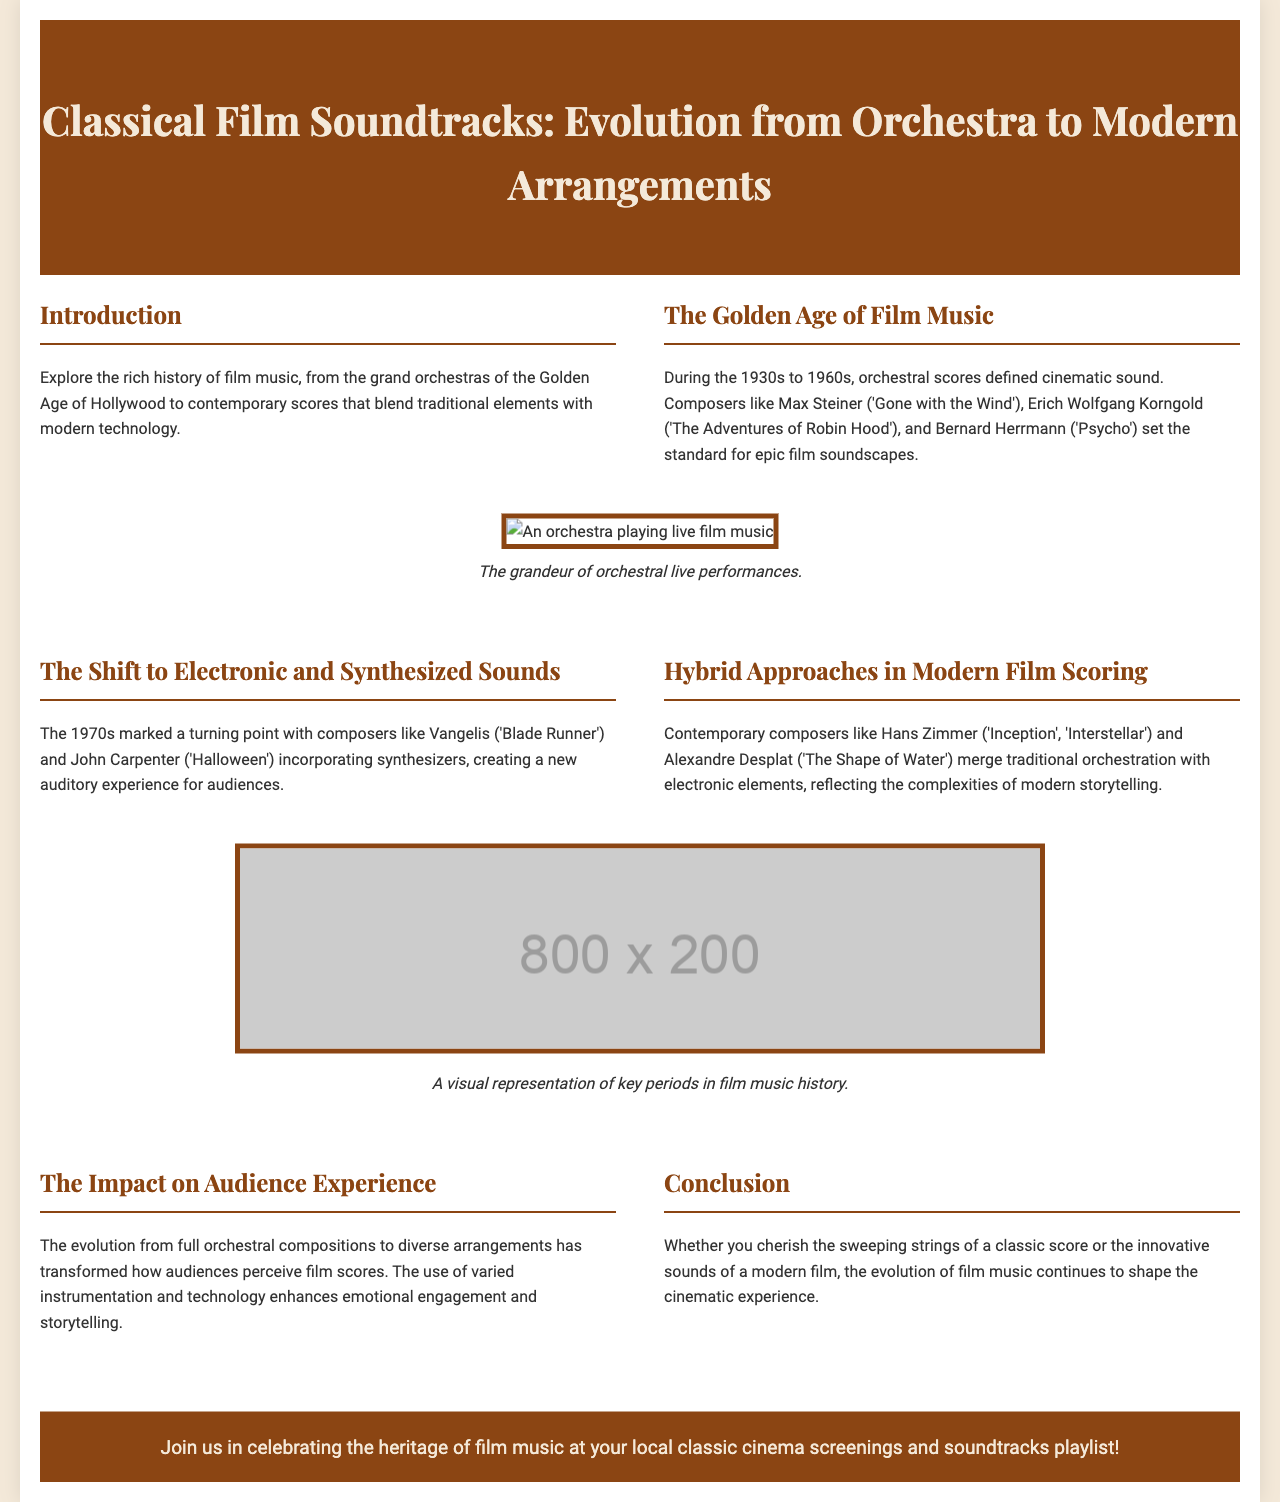What period does the Golden Age of Film Music cover? The document states that the Golden Age of Film Music occurred during the 1930s to 1960s.
Answer: 1930s to 1960s Who composed the score for 'Gone with the Wind'? The document mentions Max Steiner as the composer for 'Gone with the Wind'.
Answer: Max Steiner What technology marked a turning point in film music during the 1970s? The document indicates that synthesizers were incorporated by composers like Vangelis and John Carpenter in the 1970s.
Answer: Synthesizers Which movie is associated with Hans Zimmer in the document? The document lists 'Inception' and 'Interstellar' as films scored by Hans Zimmer.
Answer: Inception, Interstellar What unique feature is noted about contemporary film scoring? The document points out that contemporary composers merge traditional orchestration with electronic elements.
Answer: Hybrid Approaches What is the main impact of the evolution of film music on audiences? The document states that the evolution has transformed audience perceptions and emotional engagement with film scores.
Answer: Emotional engagement What does the call to action encourage people to do? The document invites readers to participate in local classic cinema screenings and soundtracks playlist.
Answer: Join classic cinema screenings Which composer is associated with 'The Shape of Water'? Alexandre Desplat is specifically mentioned in connection with 'The Shape of Water'.
Answer: Alexandre Desplat 